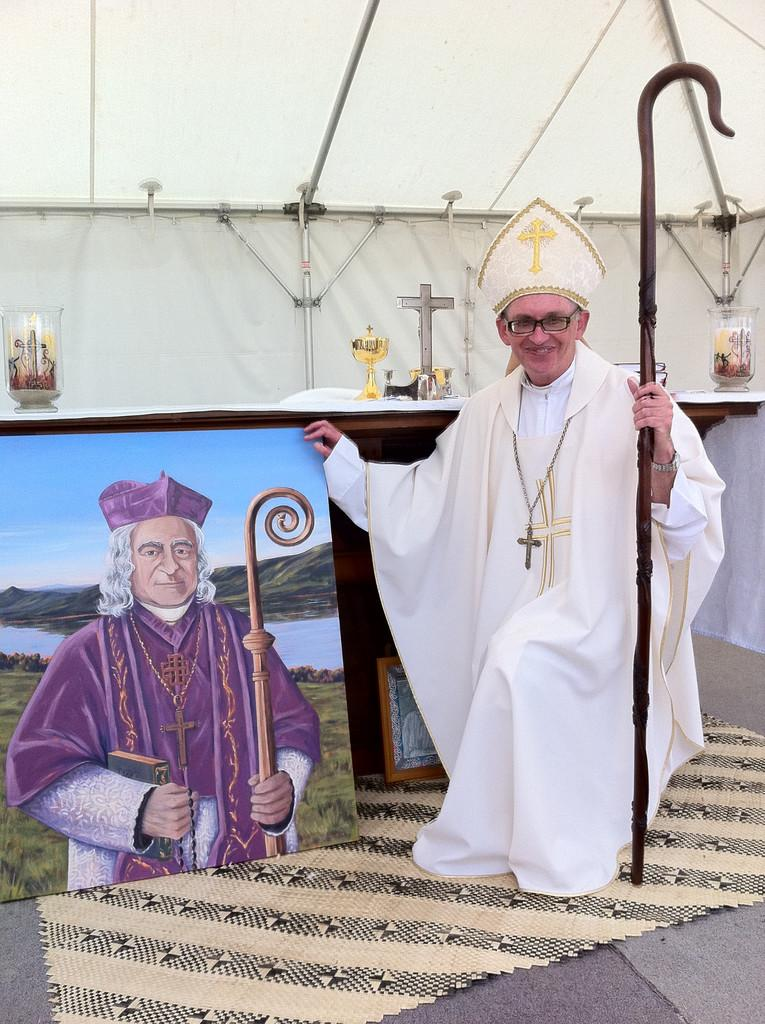Who is the main subject in the image? There is a priest in the image. What is the priest holding in the image? The priest is holding a stick. What can be seen on the left side of the image? There is a painting of a person on the left side of the image. What kind of structure is present in the image? There is a canopy in the image. How many cars are parked under the canopy in the image? There are no cars present in the image; it features a priest holding a stick, a painting of a person, and a canopy. What type of act is the priest performing in the image? There is no indication of any act being performed in the image; the priest is simply holding a stick. 